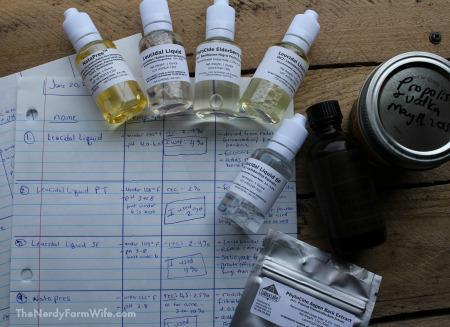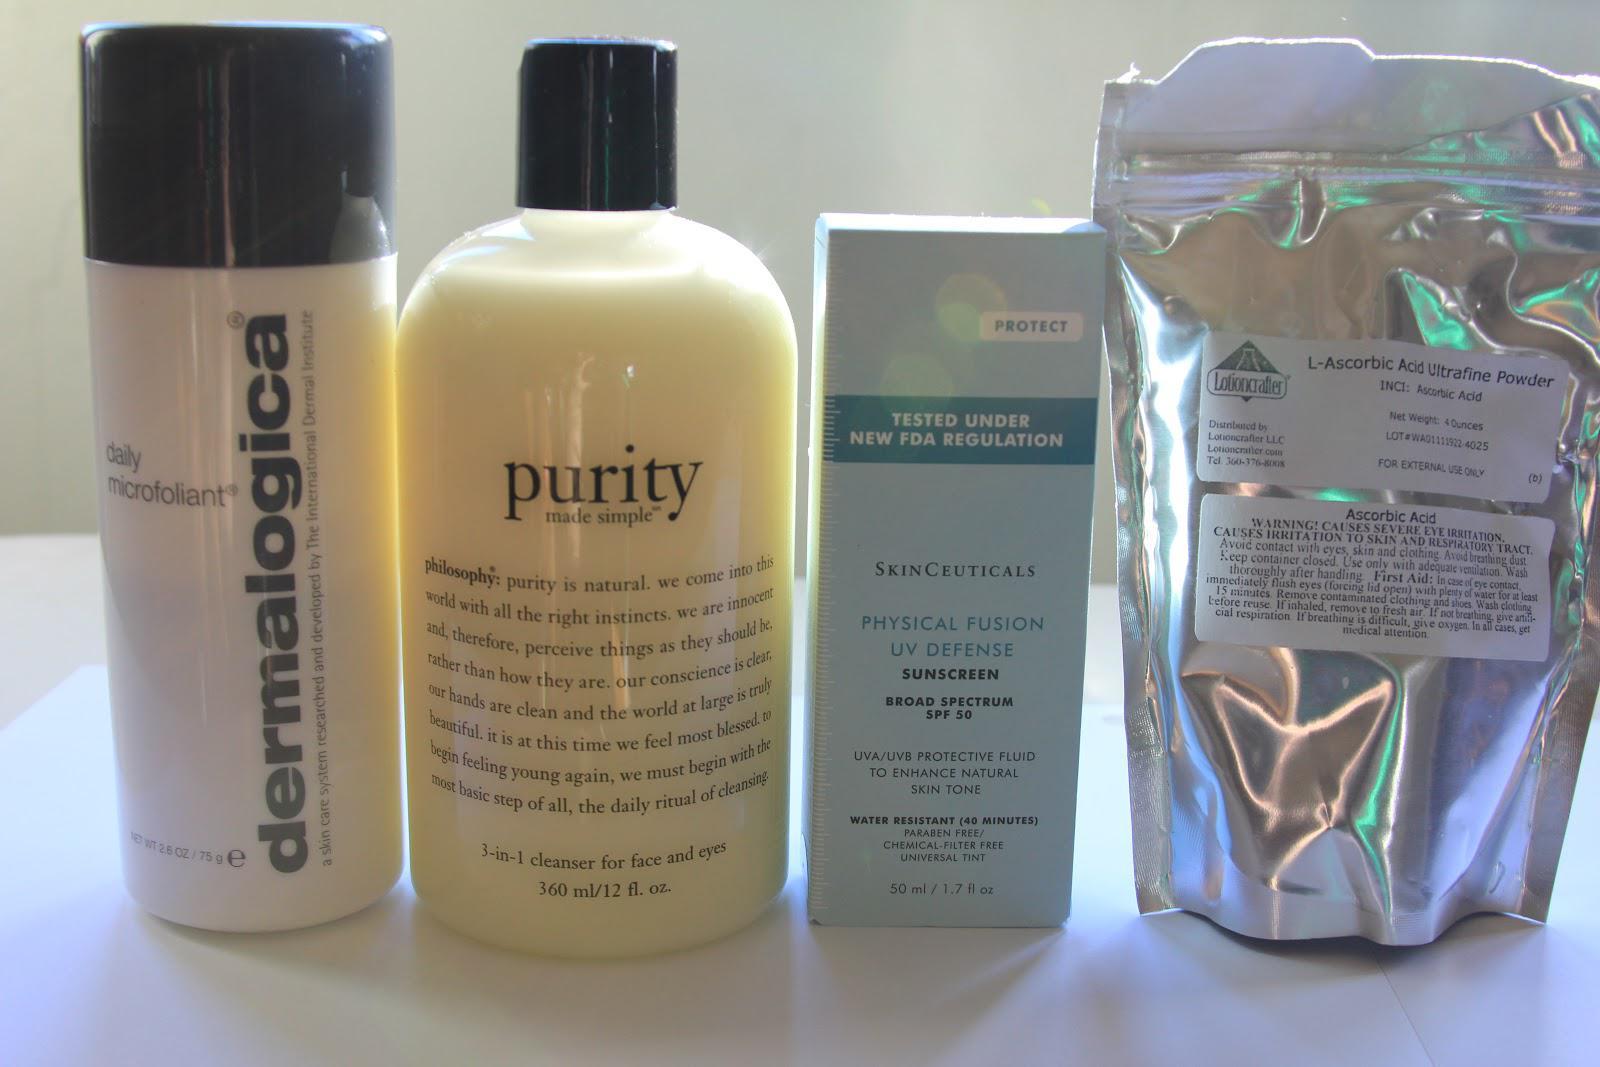The first image is the image on the left, the second image is the image on the right. For the images shown, is this caption "At least one container is open." true? Answer yes or no. No. The first image is the image on the left, the second image is the image on the right. Examine the images to the left and right. Is the description "In at least one image there is a total of five fragrance bottle with closed white caps." accurate? Answer yes or no. Yes. 